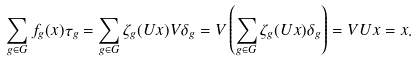<formula> <loc_0><loc_0><loc_500><loc_500>\sum _ { g \in G } f _ { g } ( x ) \tau _ { g } = \sum _ { g \in G } \zeta _ { g } ( U x ) V \delta _ { g } = V \left ( \sum _ { g \in G } \zeta _ { g } ( U x ) \delta _ { g } \right ) = V U x = x .</formula> 